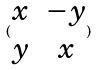<formula> <loc_0><loc_0><loc_500><loc_500>( \begin{matrix} x & - y \\ y & x \end{matrix} )</formula> 